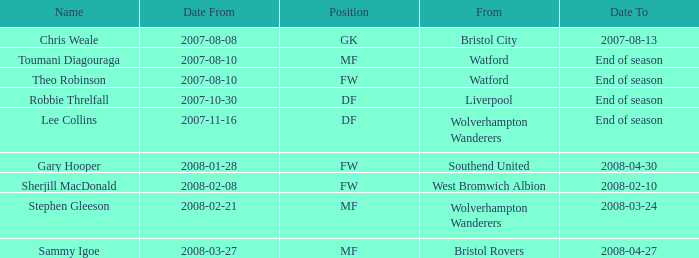Where was the player from who had the position of DF, who started 2007-10-30? Liverpool. 